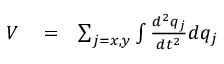<formula> <loc_0><loc_0><loc_500><loc_500>\begin{array} { r l r } { V } & = } & { \sum _ { j = x , y } \int \frac { d ^ { 2 } q _ { j } } { d t ^ { 2 } } d q _ { j } } \end{array}</formula> 